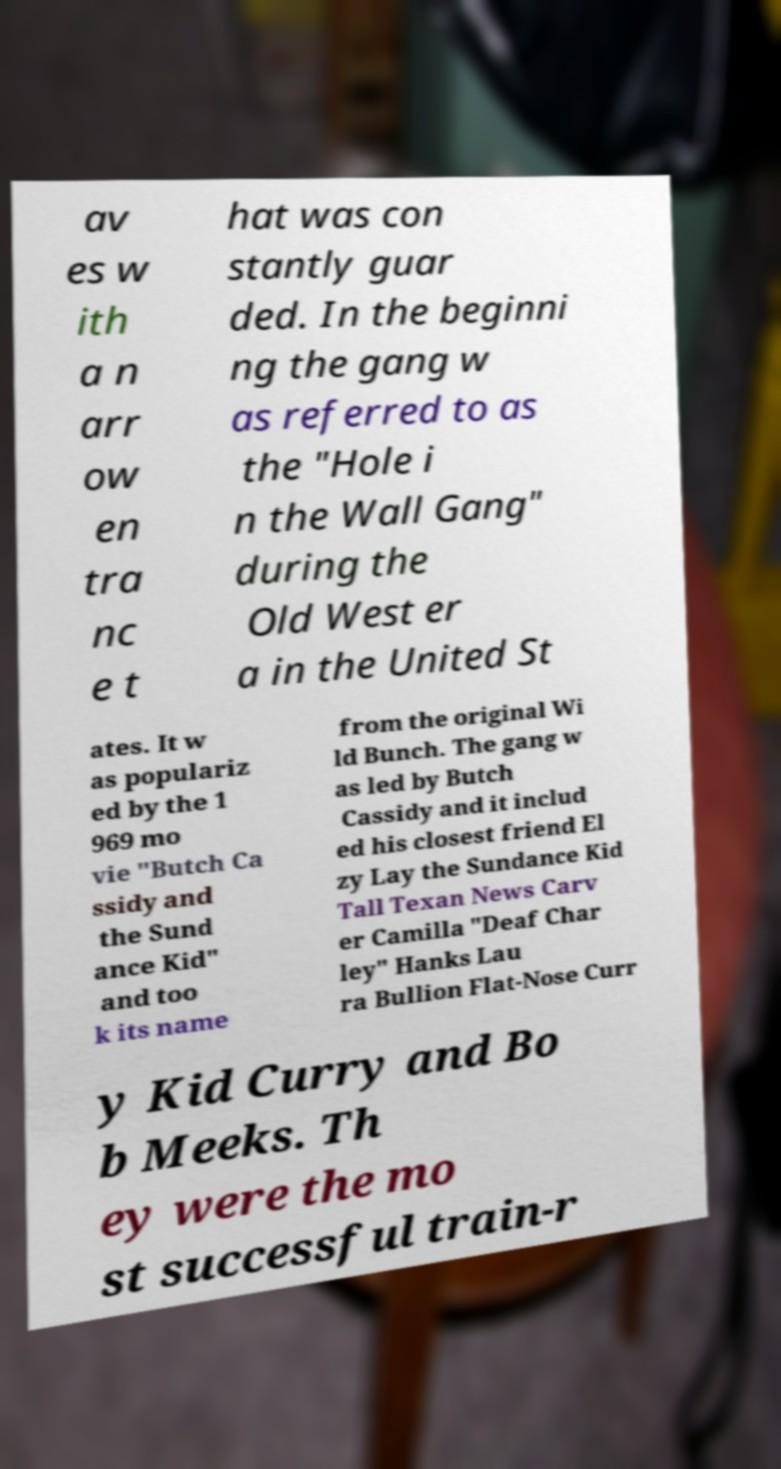Please identify and transcribe the text found in this image. av es w ith a n arr ow en tra nc e t hat was con stantly guar ded. In the beginni ng the gang w as referred to as the "Hole i n the Wall Gang" during the Old West er a in the United St ates. It w as populariz ed by the 1 969 mo vie "Butch Ca ssidy and the Sund ance Kid" and too k its name from the original Wi ld Bunch. The gang w as led by Butch Cassidy and it includ ed his closest friend El zy Lay the Sundance Kid Tall Texan News Carv er Camilla "Deaf Char ley" Hanks Lau ra Bullion Flat-Nose Curr y Kid Curry and Bo b Meeks. Th ey were the mo st successful train-r 